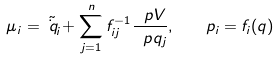<formula> <loc_0><loc_0><loc_500><loc_500>\mu _ { i } = \tilde { \dot { q } _ { i } } + \sum _ { j = 1 } ^ { n } f ^ { - 1 } _ { i j } \frac { \ p V } { \ p q _ { j } } , \quad p _ { i } = f _ { i } ( q )</formula> 